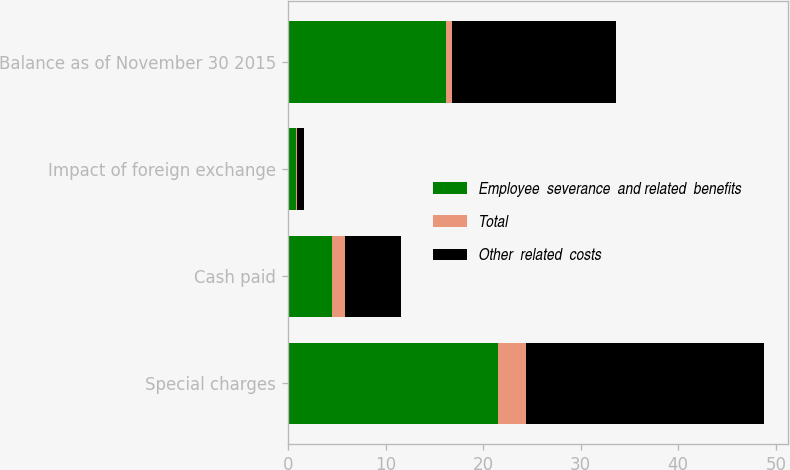<chart> <loc_0><loc_0><loc_500><loc_500><stacked_bar_chart><ecel><fcel>Special charges<fcel>Cash paid<fcel>Impact of foreign exchange<fcel>Balance as of November 30 2015<nl><fcel>Employee  severance  and related  benefits<fcel>21.5<fcel>4.5<fcel>0.8<fcel>16.2<nl><fcel>Total<fcel>2.9<fcel>1.3<fcel>0.1<fcel>0.6<nl><fcel>Other  related  costs<fcel>24.4<fcel>5.8<fcel>0.7<fcel>16.8<nl></chart> 